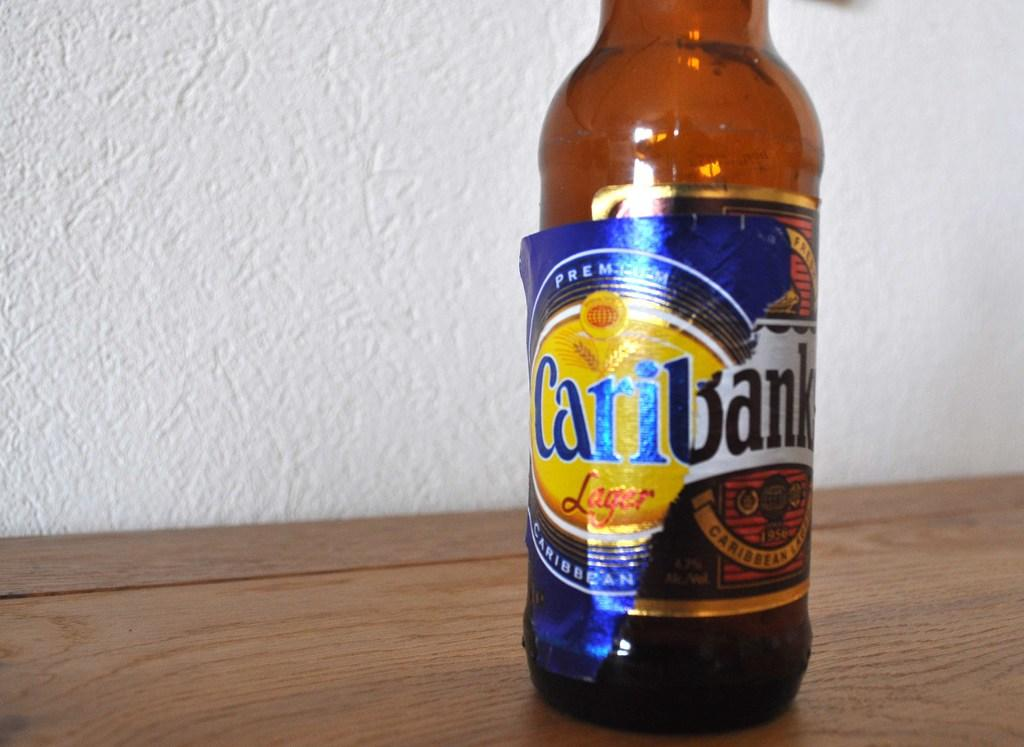What is the main object in the image? There is an alcohol bottle in the image. Where is the bottle located? The bottle is placed on a table. What can be seen on the label of the bottle? The label on the bottle says 'Cary Bank'. What is visible in the background of the image? There is a white wall visible in the background of the image. What type of engine is visible in the image? There is no engine present in the image; it features an alcohol bottle on a table with a 'Cary Bank' label. What type of metal is used to make the body of the bottle? The bottle is made of glass, not metal, and the material of the label is not specified in the image. 